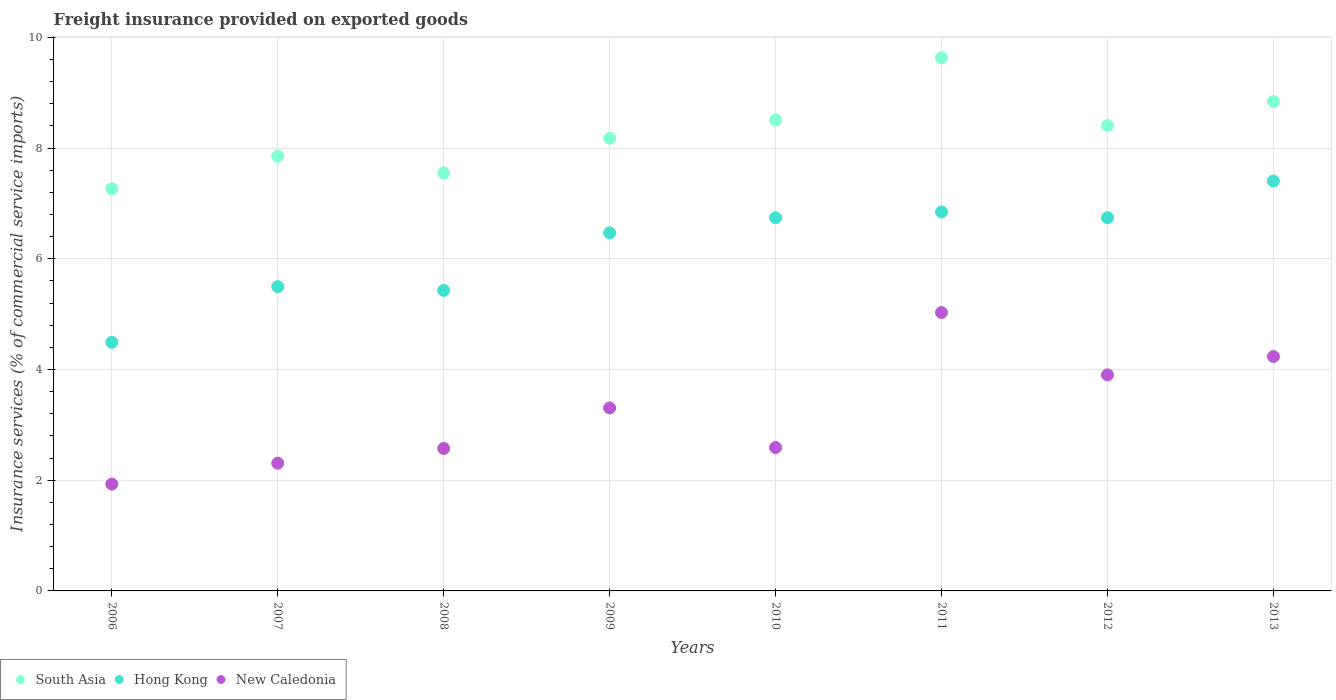What is the freight insurance provided on exported goods in South Asia in 2006?
Your answer should be very brief. 7.27. Across all years, what is the maximum freight insurance provided on exported goods in New Caledonia?
Make the answer very short. 5.03. Across all years, what is the minimum freight insurance provided on exported goods in New Caledonia?
Provide a succinct answer. 1.93. In which year was the freight insurance provided on exported goods in South Asia maximum?
Your response must be concise. 2011. In which year was the freight insurance provided on exported goods in New Caledonia minimum?
Give a very brief answer. 2006. What is the total freight insurance provided on exported goods in South Asia in the graph?
Your answer should be compact. 66.23. What is the difference between the freight insurance provided on exported goods in South Asia in 2006 and that in 2013?
Make the answer very short. -1.57. What is the difference between the freight insurance provided on exported goods in South Asia in 2011 and the freight insurance provided on exported goods in New Caledonia in 2012?
Ensure brevity in your answer.  5.73. What is the average freight insurance provided on exported goods in South Asia per year?
Your response must be concise. 8.28. In the year 2006, what is the difference between the freight insurance provided on exported goods in New Caledonia and freight insurance provided on exported goods in South Asia?
Your answer should be compact. -5.34. In how many years, is the freight insurance provided on exported goods in Hong Kong greater than 9.6 %?
Provide a short and direct response. 0. What is the ratio of the freight insurance provided on exported goods in Hong Kong in 2006 to that in 2013?
Offer a terse response. 0.61. Is the difference between the freight insurance provided on exported goods in New Caledonia in 2008 and 2010 greater than the difference between the freight insurance provided on exported goods in South Asia in 2008 and 2010?
Provide a short and direct response. Yes. What is the difference between the highest and the second highest freight insurance provided on exported goods in Hong Kong?
Make the answer very short. 0.56. What is the difference between the highest and the lowest freight insurance provided on exported goods in Hong Kong?
Your answer should be compact. 2.91. In how many years, is the freight insurance provided on exported goods in New Caledonia greater than the average freight insurance provided on exported goods in New Caledonia taken over all years?
Your answer should be compact. 4. Is the sum of the freight insurance provided on exported goods in New Caledonia in 2010 and 2012 greater than the maximum freight insurance provided on exported goods in Hong Kong across all years?
Offer a very short reply. No. Is it the case that in every year, the sum of the freight insurance provided on exported goods in South Asia and freight insurance provided on exported goods in New Caledonia  is greater than the freight insurance provided on exported goods in Hong Kong?
Make the answer very short. Yes. Is the freight insurance provided on exported goods in Hong Kong strictly greater than the freight insurance provided on exported goods in New Caledonia over the years?
Provide a short and direct response. Yes. How many dotlines are there?
Offer a terse response. 3. How many years are there in the graph?
Provide a succinct answer. 8. What is the difference between two consecutive major ticks on the Y-axis?
Offer a terse response. 2. Does the graph contain grids?
Offer a very short reply. Yes. How are the legend labels stacked?
Provide a short and direct response. Horizontal. What is the title of the graph?
Your response must be concise. Freight insurance provided on exported goods. Does "Myanmar" appear as one of the legend labels in the graph?
Keep it short and to the point. No. What is the label or title of the Y-axis?
Your answer should be compact. Insurance services (% of commercial service imports). What is the Insurance services (% of commercial service imports) of South Asia in 2006?
Keep it short and to the point. 7.27. What is the Insurance services (% of commercial service imports) in Hong Kong in 2006?
Offer a terse response. 4.49. What is the Insurance services (% of commercial service imports) in New Caledonia in 2006?
Your response must be concise. 1.93. What is the Insurance services (% of commercial service imports) in South Asia in 2007?
Offer a terse response. 7.85. What is the Insurance services (% of commercial service imports) in Hong Kong in 2007?
Your answer should be compact. 5.5. What is the Insurance services (% of commercial service imports) of New Caledonia in 2007?
Your response must be concise. 2.31. What is the Insurance services (% of commercial service imports) of South Asia in 2008?
Provide a succinct answer. 7.55. What is the Insurance services (% of commercial service imports) of Hong Kong in 2008?
Your answer should be very brief. 5.43. What is the Insurance services (% of commercial service imports) in New Caledonia in 2008?
Your response must be concise. 2.57. What is the Insurance services (% of commercial service imports) in South Asia in 2009?
Your answer should be very brief. 8.18. What is the Insurance services (% of commercial service imports) in Hong Kong in 2009?
Provide a succinct answer. 6.47. What is the Insurance services (% of commercial service imports) in New Caledonia in 2009?
Your answer should be compact. 3.31. What is the Insurance services (% of commercial service imports) of South Asia in 2010?
Provide a short and direct response. 8.51. What is the Insurance services (% of commercial service imports) of Hong Kong in 2010?
Make the answer very short. 6.74. What is the Insurance services (% of commercial service imports) in New Caledonia in 2010?
Make the answer very short. 2.59. What is the Insurance services (% of commercial service imports) in South Asia in 2011?
Ensure brevity in your answer.  9.63. What is the Insurance services (% of commercial service imports) of Hong Kong in 2011?
Provide a succinct answer. 6.85. What is the Insurance services (% of commercial service imports) of New Caledonia in 2011?
Offer a very short reply. 5.03. What is the Insurance services (% of commercial service imports) in South Asia in 2012?
Offer a terse response. 8.41. What is the Insurance services (% of commercial service imports) of Hong Kong in 2012?
Your answer should be very brief. 6.74. What is the Insurance services (% of commercial service imports) of New Caledonia in 2012?
Ensure brevity in your answer.  3.9. What is the Insurance services (% of commercial service imports) of South Asia in 2013?
Ensure brevity in your answer.  8.84. What is the Insurance services (% of commercial service imports) in Hong Kong in 2013?
Give a very brief answer. 7.4. What is the Insurance services (% of commercial service imports) in New Caledonia in 2013?
Offer a very short reply. 4.23. Across all years, what is the maximum Insurance services (% of commercial service imports) in South Asia?
Ensure brevity in your answer.  9.63. Across all years, what is the maximum Insurance services (% of commercial service imports) of Hong Kong?
Offer a very short reply. 7.4. Across all years, what is the maximum Insurance services (% of commercial service imports) in New Caledonia?
Your answer should be compact. 5.03. Across all years, what is the minimum Insurance services (% of commercial service imports) of South Asia?
Your response must be concise. 7.27. Across all years, what is the minimum Insurance services (% of commercial service imports) of Hong Kong?
Offer a very short reply. 4.49. Across all years, what is the minimum Insurance services (% of commercial service imports) of New Caledonia?
Your answer should be very brief. 1.93. What is the total Insurance services (% of commercial service imports) in South Asia in the graph?
Your response must be concise. 66.23. What is the total Insurance services (% of commercial service imports) of Hong Kong in the graph?
Your response must be concise. 49.62. What is the total Insurance services (% of commercial service imports) in New Caledonia in the graph?
Your response must be concise. 25.87. What is the difference between the Insurance services (% of commercial service imports) in South Asia in 2006 and that in 2007?
Offer a terse response. -0.59. What is the difference between the Insurance services (% of commercial service imports) of Hong Kong in 2006 and that in 2007?
Your answer should be very brief. -1.01. What is the difference between the Insurance services (% of commercial service imports) in New Caledonia in 2006 and that in 2007?
Ensure brevity in your answer.  -0.38. What is the difference between the Insurance services (% of commercial service imports) in South Asia in 2006 and that in 2008?
Ensure brevity in your answer.  -0.29. What is the difference between the Insurance services (% of commercial service imports) of Hong Kong in 2006 and that in 2008?
Offer a very short reply. -0.94. What is the difference between the Insurance services (% of commercial service imports) in New Caledonia in 2006 and that in 2008?
Provide a succinct answer. -0.64. What is the difference between the Insurance services (% of commercial service imports) in South Asia in 2006 and that in 2009?
Make the answer very short. -0.91. What is the difference between the Insurance services (% of commercial service imports) of Hong Kong in 2006 and that in 2009?
Keep it short and to the point. -1.98. What is the difference between the Insurance services (% of commercial service imports) in New Caledonia in 2006 and that in 2009?
Make the answer very short. -1.38. What is the difference between the Insurance services (% of commercial service imports) of South Asia in 2006 and that in 2010?
Make the answer very short. -1.24. What is the difference between the Insurance services (% of commercial service imports) of Hong Kong in 2006 and that in 2010?
Make the answer very short. -2.25. What is the difference between the Insurance services (% of commercial service imports) of New Caledonia in 2006 and that in 2010?
Give a very brief answer. -0.66. What is the difference between the Insurance services (% of commercial service imports) of South Asia in 2006 and that in 2011?
Provide a short and direct response. -2.36. What is the difference between the Insurance services (% of commercial service imports) in Hong Kong in 2006 and that in 2011?
Give a very brief answer. -2.35. What is the difference between the Insurance services (% of commercial service imports) of New Caledonia in 2006 and that in 2011?
Your answer should be very brief. -3.1. What is the difference between the Insurance services (% of commercial service imports) in South Asia in 2006 and that in 2012?
Ensure brevity in your answer.  -1.14. What is the difference between the Insurance services (% of commercial service imports) in Hong Kong in 2006 and that in 2012?
Your answer should be very brief. -2.25. What is the difference between the Insurance services (% of commercial service imports) of New Caledonia in 2006 and that in 2012?
Provide a succinct answer. -1.97. What is the difference between the Insurance services (% of commercial service imports) in South Asia in 2006 and that in 2013?
Offer a very short reply. -1.57. What is the difference between the Insurance services (% of commercial service imports) in Hong Kong in 2006 and that in 2013?
Make the answer very short. -2.91. What is the difference between the Insurance services (% of commercial service imports) of New Caledonia in 2006 and that in 2013?
Keep it short and to the point. -2.31. What is the difference between the Insurance services (% of commercial service imports) in South Asia in 2007 and that in 2008?
Offer a very short reply. 0.3. What is the difference between the Insurance services (% of commercial service imports) of Hong Kong in 2007 and that in 2008?
Ensure brevity in your answer.  0.07. What is the difference between the Insurance services (% of commercial service imports) of New Caledonia in 2007 and that in 2008?
Provide a short and direct response. -0.27. What is the difference between the Insurance services (% of commercial service imports) in South Asia in 2007 and that in 2009?
Your response must be concise. -0.32. What is the difference between the Insurance services (% of commercial service imports) of Hong Kong in 2007 and that in 2009?
Ensure brevity in your answer.  -0.97. What is the difference between the Insurance services (% of commercial service imports) of New Caledonia in 2007 and that in 2009?
Provide a short and direct response. -1. What is the difference between the Insurance services (% of commercial service imports) in South Asia in 2007 and that in 2010?
Keep it short and to the point. -0.66. What is the difference between the Insurance services (% of commercial service imports) in Hong Kong in 2007 and that in 2010?
Your answer should be very brief. -1.24. What is the difference between the Insurance services (% of commercial service imports) of New Caledonia in 2007 and that in 2010?
Give a very brief answer. -0.28. What is the difference between the Insurance services (% of commercial service imports) in South Asia in 2007 and that in 2011?
Give a very brief answer. -1.78. What is the difference between the Insurance services (% of commercial service imports) of Hong Kong in 2007 and that in 2011?
Your response must be concise. -1.35. What is the difference between the Insurance services (% of commercial service imports) of New Caledonia in 2007 and that in 2011?
Make the answer very short. -2.72. What is the difference between the Insurance services (% of commercial service imports) in South Asia in 2007 and that in 2012?
Provide a succinct answer. -0.56. What is the difference between the Insurance services (% of commercial service imports) of Hong Kong in 2007 and that in 2012?
Give a very brief answer. -1.25. What is the difference between the Insurance services (% of commercial service imports) of New Caledonia in 2007 and that in 2012?
Keep it short and to the point. -1.6. What is the difference between the Insurance services (% of commercial service imports) of South Asia in 2007 and that in 2013?
Ensure brevity in your answer.  -0.99. What is the difference between the Insurance services (% of commercial service imports) of Hong Kong in 2007 and that in 2013?
Provide a succinct answer. -1.91. What is the difference between the Insurance services (% of commercial service imports) in New Caledonia in 2007 and that in 2013?
Offer a terse response. -1.93. What is the difference between the Insurance services (% of commercial service imports) of South Asia in 2008 and that in 2009?
Provide a succinct answer. -0.63. What is the difference between the Insurance services (% of commercial service imports) in Hong Kong in 2008 and that in 2009?
Keep it short and to the point. -1.04. What is the difference between the Insurance services (% of commercial service imports) of New Caledonia in 2008 and that in 2009?
Your answer should be compact. -0.73. What is the difference between the Insurance services (% of commercial service imports) in South Asia in 2008 and that in 2010?
Keep it short and to the point. -0.96. What is the difference between the Insurance services (% of commercial service imports) of Hong Kong in 2008 and that in 2010?
Provide a short and direct response. -1.31. What is the difference between the Insurance services (% of commercial service imports) in New Caledonia in 2008 and that in 2010?
Provide a succinct answer. -0.02. What is the difference between the Insurance services (% of commercial service imports) in South Asia in 2008 and that in 2011?
Offer a terse response. -2.08. What is the difference between the Insurance services (% of commercial service imports) in Hong Kong in 2008 and that in 2011?
Your answer should be compact. -1.42. What is the difference between the Insurance services (% of commercial service imports) of New Caledonia in 2008 and that in 2011?
Offer a terse response. -2.46. What is the difference between the Insurance services (% of commercial service imports) of South Asia in 2008 and that in 2012?
Offer a very short reply. -0.86. What is the difference between the Insurance services (% of commercial service imports) of Hong Kong in 2008 and that in 2012?
Your answer should be compact. -1.31. What is the difference between the Insurance services (% of commercial service imports) in New Caledonia in 2008 and that in 2012?
Your answer should be very brief. -1.33. What is the difference between the Insurance services (% of commercial service imports) in South Asia in 2008 and that in 2013?
Give a very brief answer. -1.29. What is the difference between the Insurance services (% of commercial service imports) in Hong Kong in 2008 and that in 2013?
Make the answer very short. -1.98. What is the difference between the Insurance services (% of commercial service imports) of New Caledonia in 2008 and that in 2013?
Offer a very short reply. -1.66. What is the difference between the Insurance services (% of commercial service imports) in South Asia in 2009 and that in 2010?
Offer a very short reply. -0.33. What is the difference between the Insurance services (% of commercial service imports) in Hong Kong in 2009 and that in 2010?
Provide a succinct answer. -0.27. What is the difference between the Insurance services (% of commercial service imports) in New Caledonia in 2009 and that in 2010?
Provide a short and direct response. 0.71. What is the difference between the Insurance services (% of commercial service imports) of South Asia in 2009 and that in 2011?
Keep it short and to the point. -1.45. What is the difference between the Insurance services (% of commercial service imports) of Hong Kong in 2009 and that in 2011?
Give a very brief answer. -0.38. What is the difference between the Insurance services (% of commercial service imports) of New Caledonia in 2009 and that in 2011?
Offer a terse response. -1.72. What is the difference between the Insurance services (% of commercial service imports) in South Asia in 2009 and that in 2012?
Offer a very short reply. -0.23. What is the difference between the Insurance services (% of commercial service imports) of Hong Kong in 2009 and that in 2012?
Provide a short and direct response. -0.27. What is the difference between the Insurance services (% of commercial service imports) of New Caledonia in 2009 and that in 2012?
Offer a very short reply. -0.6. What is the difference between the Insurance services (% of commercial service imports) of South Asia in 2009 and that in 2013?
Offer a very short reply. -0.66. What is the difference between the Insurance services (% of commercial service imports) of Hong Kong in 2009 and that in 2013?
Your answer should be very brief. -0.94. What is the difference between the Insurance services (% of commercial service imports) in New Caledonia in 2009 and that in 2013?
Offer a very short reply. -0.93. What is the difference between the Insurance services (% of commercial service imports) in South Asia in 2010 and that in 2011?
Ensure brevity in your answer.  -1.12. What is the difference between the Insurance services (% of commercial service imports) in Hong Kong in 2010 and that in 2011?
Keep it short and to the point. -0.1. What is the difference between the Insurance services (% of commercial service imports) in New Caledonia in 2010 and that in 2011?
Provide a succinct answer. -2.44. What is the difference between the Insurance services (% of commercial service imports) of South Asia in 2010 and that in 2012?
Make the answer very short. 0.1. What is the difference between the Insurance services (% of commercial service imports) of Hong Kong in 2010 and that in 2012?
Provide a short and direct response. -0. What is the difference between the Insurance services (% of commercial service imports) of New Caledonia in 2010 and that in 2012?
Make the answer very short. -1.31. What is the difference between the Insurance services (% of commercial service imports) of South Asia in 2010 and that in 2013?
Provide a succinct answer. -0.33. What is the difference between the Insurance services (% of commercial service imports) in Hong Kong in 2010 and that in 2013?
Make the answer very short. -0.66. What is the difference between the Insurance services (% of commercial service imports) in New Caledonia in 2010 and that in 2013?
Provide a succinct answer. -1.64. What is the difference between the Insurance services (% of commercial service imports) of South Asia in 2011 and that in 2012?
Your answer should be compact. 1.22. What is the difference between the Insurance services (% of commercial service imports) of Hong Kong in 2011 and that in 2012?
Offer a very short reply. 0.1. What is the difference between the Insurance services (% of commercial service imports) of New Caledonia in 2011 and that in 2012?
Your response must be concise. 1.13. What is the difference between the Insurance services (% of commercial service imports) in South Asia in 2011 and that in 2013?
Your answer should be very brief. 0.79. What is the difference between the Insurance services (% of commercial service imports) in Hong Kong in 2011 and that in 2013?
Keep it short and to the point. -0.56. What is the difference between the Insurance services (% of commercial service imports) in New Caledonia in 2011 and that in 2013?
Your answer should be compact. 0.79. What is the difference between the Insurance services (% of commercial service imports) of South Asia in 2012 and that in 2013?
Your response must be concise. -0.43. What is the difference between the Insurance services (% of commercial service imports) of Hong Kong in 2012 and that in 2013?
Offer a terse response. -0.66. What is the difference between the Insurance services (% of commercial service imports) in New Caledonia in 2012 and that in 2013?
Provide a succinct answer. -0.33. What is the difference between the Insurance services (% of commercial service imports) in South Asia in 2006 and the Insurance services (% of commercial service imports) in Hong Kong in 2007?
Provide a succinct answer. 1.77. What is the difference between the Insurance services (% of commercial service imports) in South Asia in 2006 and the Insurance services (% of commercial service imports) in New Caledonia in 2007?
Your response must be concise. 4.96. What is the difference between the Insurance services (% of commercial service imports) of Hong Kong in 2006 and the Insurance services (% of commercial service imports) of New Caledonia in 2007?
Provide a succinct answer. 2.18. What is the difference between the Insurance services (% of commercial service imports) in South Asia in 2006 and the Insurance services (% of commercial service imports) in Hong Kong in 2008?
Your response must be concise. 1.84. What is the difference between the Insurance services (% of commercial service imports) of South Asia in 2006 and the Insurance services (% of commercial service imports) of New Caledonia in 2008?
Make the answer very short. 4.69. What is the difference between the Insurance services (% of commercial service imports) of Hong Kong in 2006 and the Insurance services (% of commercial service imports) of New Caledonia in 2008?
Make the answer very short. 1.92. What is the difference between the Insurance services (% of commercial service imports) of South Asia in 2006 and the Insurance services (% of commercial service imports) of Hong Kong in 2009?
Give a very brief answer. 0.8. What is the difference between the Insurance services (% of commercial service imports) in South Asia in 2006 and the Insurance services (% of commercial service imports) in New Caledonia in 2009?
Make the answer very short. 3.96. What is the difference between the Insurance services (% of commercial service imports) in Hong Kong in 2006 and the Insurance services (% of commercial service imports) in New Caledonia in 2009?
Your answer should be very brief. 1.19. What is the difference between the Insurance services (% of commercial service imports) of South Asia in 2006 and the Insurance services (% of commercial service imports) of Hong Kong in 2010?
Your response must be concise. 0.52. What is the difference between the Insurance services (% of commercial service imports) of South Asia in 2006 and the Insurance services (% of commercial service imports) of New Caledonia in 2010?
Ensure brevity in your answer.  4.68. What is the difference between the Insurance services (% of commercial service imports) of Hong Kong in 2006 and the Insurance services (% of commercial service imports) of New Caledonia in 2010?
Your answer should be very brief. 1.9. What is the difference between the Insurance services (% of commercial service imports) of South Asia in 2006 and the Insurance services (% of commercial service imports) of Hong Kong in 2011?
Provide a succinct answer. 0.42. What is the difference between the Insurance services (% of commercial service imports) of South Asia in 2006 and the Insurance services (% of commercial service imports) of New Caledonia in 2011?
Provide a succinct answer. 2.24. What is the difference between the Insurance services (% of commercial service imports) of Hong Kong in 2006 and the Insurance services (% of commercial service imports) of New Caledonia in 2011?
Provide a short and direct response. -0.54. What is the difference between the Insurance services (% of commercial service imports) of South Asia in 2006 and the Insurance services (% of commercial service imports) of Hong Kong in 2012?
Offer a very short reply. 0.52. What is the difference between the Insurance services (% of commercial service imports) in South Asia in 2006 and the Insurance services (% of commercial service imports) in New Caledonia in 2012?
Keep it short and to the point. 3.36. What is the difference between the Insurance services (% of commercial service imports) in Hong Kong in 2006 and the Insurance services (% of commercial service imports) in New Caledonia in 2012?
Give a very brief answer. 0.59. What is the difference between the Insurance services (% of commercial service imports) in South Asia in 2006 and the Insurance services (% of commercial service imports) in Hong Kong in 2013?
Provide a short and direct response. -0.14. What is the difference between the Insurance services (% of commercial service imports) in South Asia in 2006 and the Insurance services (% of commercial service imports) in New Caledonia in 2013?
Offer a very short reply. 3.03. What is the difference between the Insurance services (% of commercial service imports) in Hong Kong in 2006 and the Insurance services (% of commercial service imports) in New Caledonia in 2013?
Give a very brief answer. 0.26. What is the difference between the Insurance services (% of commercial service imports) in South Asia in 2007 and the Insurance services (% of commercial service imports) in Hong Kong in 2008?
Provide a succinct answer. 2.42. What is the difference between the Insurance services (% of commercial service imports) of South Asia in 2007 and the Insurance services (% of commercial service imports) of New Caledonia in 2008?
Provide a short and direct response. 5.28. What is the difference between the Insurance services (% of commercial service imports) of Hong Kong in 2007 and the Insurance services (% of commercial service imports) of New Caledonia in 2008?
Ensure brevity in your answer.  2.92. What is the difference between the Insurance services (% of commercial service imports) in South Asia in 2007 and the Insurance services (% of commercial service imports) in Hong Kong in 2009?
Offer a terse response. 1.38. What is the difference between the Insurance services (% of commercial service imports) of South Asia in 2007 and the Insurance services (% of commercial service imports) of New Caledonia in 2009?
Provide a succinct answer. 4.55. What is the difference between the Insurance services (% of commercial service imports) in Hong Kong in 2007 and the Insurance services (% of commercial service imports) in New Caledonia in 2009?
Provide a short and direct response. 2.19. What is the difference between the Insurance services (% of commercial service imports) in South Asia in 2007 and the Insurance services (% of commercial service imports) in Hong Kong in 2010?
Give a very brief answer. 1.11. What is the difference between the Insurance services (% of commercial service imports) in South Asia in 2007 and the Insurance services (% of commercial service imports) in New Caledonia in 2010?
Ensure brevity in your answer.  5.26. What is the difference between the Insurance services (% of commercial service imports) in Hong Kong in 2007 and the Insurance services (% of commercial service imports) in New Caledonia in 2010?
Give a very brief answer. 2.91. What is the difference between the Insurance services (% of commercial service imports) of South Asia in 2007 and the Insurance services (% of commercial service imports) of New Caledonia in 2011?
Give a very brief answer. 2.82. What is the difference between the Insurance services (% of commercial service imports) in Hong Kong in 2007 and the Insurance services (% of commercial service imports) in New Caledonia in 2011?
Keep it short and to the point. 0.47. What is the difference between the Insurance services (% of commercial service imports) in South Asia in 2007 and the Insurance services (% of commercial service imports) in Hong Kong in 2012?
Give a very brief answer. 1.11. What is the difference between the Insurance services (% of commercial service imports) in South Asia in 2007 and the Insurance services (% of commercial service imports) in New Caledonia in 2012?
Provide a succinct answer. 3.95. What is the difference between the Insurance services (% of commercial service imports) of Hong Kong in 2007 and the Insurance services (% of commercial service imports) of New Caledonia in 2012?
Your answer should be compact. 1.59. What is the difference between the Insurance services (% of commercial service imports) in South Asia in 2007 and the Insurance services (% of commercial service imports) in Hong Kong in 2013?
Give a very brief answer. 0.45. What is the difference between the Insurance services (% of commercial service imports) in South Asia in 2007 and the Insurance services (% of commercial service imports) in New Caledonia in 2013?
Your answer should be compact. 3.62. What is the difference between the Insurance services (% of commercial service imports) of Hong Kong in 2007 and the Insurance services (% of commercial service imports) of New Caledonia in 2013?
Provide a short and direct response. 1.26. What is the difference between the Insurance services (% of commercial service imports) in South Asia in 2008 and the Insurance services (% of commercial service imports) in Hong Kong in 2009?
Ensure brevity in your answer.  1.08. What is the difference between the Insurance services (% of commercial service imports) of South Asia in 2008 and the Insurance services (% of commercial service imports) of New Caledonia in 2009?
Your response must be concise. 4.25. What is the difference between the Insurance services (% of commercial service imports) in Hong Kong in 2008 and the Insurance services (% of commercial service imports) in New Caledonia in 2009?
Provide a short and direct response. 2.12. What is the difference between the Insurance services (% of commercial service imports) in South Asia in 2008 and the Insurance services (% of commercial service imports) in Hong Kong in 2010?
Offer a terse response. 0.81. What is the difference between the Insurance services (% of commercial service imports) in South Asia in 2008 and the Insurance services (% of commercial service imports) in New Caledonia in 2010?
Keep it short and to the point. 4.96. What is the difference between the Insurance services (% of commercial service imports) of Hong Kong in 2008 and the Insurance services (% of commercial service imports) of New Caledonia in 2010?
Ensure brevity in your answer.  2.84. What is the difference between the Insurance services (% of commercial service imports) of South Asia in 2008 and the Insurance services (% of commercial service imports) of Hong Kong in 2011?
Provide a short and direct response. 0.71. What is the difference between the Insurance services (% of commercial service imports) of South Asia in 2008 and the Insurance services (% of commercial service imports) of New Caledonia in 2011?
Offer a terse response. 2.52. What is the difference between the Insurance services (% of commercial service imports) of Hong Kong in 2008 and the Insurance services (% of commercial service imports) of New Caledonia in 2011?
Ensure brevity in your answer.  0.4. What is the difference between the Insurance services (% of commercial service imports) of South Asia in 2008 and the Insurance services (% of commercial service imports) of Hong Kong in 2012?
Give a very brief answer. 0.81. What is the difference between the Insurance services (% of commercial service imports) of South Asia in 2008 and the Insurance services (% of commercial service imports) of New Caledonia in 2012?
Keep it short and to the point. 3.65. What is the difference between the Insurance services (% of commercial service imports) of Hong Kong in 2008 and the Insurance services (% of commercial service imports) of New Caledonia in 2012?
Provide a short and direct response. 1.53. What is the difference between the Insurance services (% of commercial service imports) in South Asia in 2008 and the Insurance services (% of commercial service imports) in Hong Kong in 2013?
Keep it short and to the point. 0.15. What is the difference between the Insurance services (% of commercial service imports) in South Asia in 2008 and the Insurance services (% of commercial service imports) in New Caledonia in 2013?
Give a very brief answer. 3.32. What is the difference between the Insurance services (% of commercial service imports) of Hong Kong in 2008 and the Insurance services (% of commercial service imports) of New Caledonia in 2013?
Keep it short and to the point. 1.19. What is the difference between the Insurance services (% of commercial service imports) of South Asia in 2009 and the Insurance services (% of commercial service imports) of Hong Kong in 2010?
Provide a short and direct response. 1.44. What is the difference between the Insurance services (% of commercial service imports) in South Asia in 2009 and the Insurance services (% of commercial service imports) in New Caledonia in 2010?
Give a very brief answer. 5.59. What is the difference between the Insurance services (% of commercial service imports) of Hong Kong in 2009 and the Insurance services (% of commercial service imports) of New Caledonia in 2010?
Ensure brevity in your answer.  3.88. What is the difference between the Insurance services (% of commercial service imports) in South Asia in 2009 and the Insurance services (% of commercial service imports) in Hong Kong in 2011?
Offer a terse response. 1.33. What is the difference between the Insurance services (% of commercial service imports) in South Asia in 2009 and the Insurance services (% of commercial service imports) in New Caledonia in 2011?
Provide a short and direct response. 3.15. What is the difference between the Insurance services (% of commercial service imports) of Hong Kong in 2009 and the Insurance services (% of commercial service imports) of New Caledonia in 2011?
Offer a very short reply. 1.44. What is the difference between the Insurance services (% of commercial service imports) in South Asia in 2009 and the Insurance services (% of commercial service imports) in Hong Kong in 2012?
Offer a very short reply. 1.43. What is the difference between the Insurance services (% of commercial service imports) in South Asia in 2009 and the Insurance services (% of commercial service imports) in New Caledonia in 2012?
Ensure brevity in your answer.  4.27. What is the difference between the Insurance services (% of commercial service imports) of Hong Kong in 2009 and the Insurance services (% of commercial service imports) of New Caledonia in 2012?
Your answer should be very brief. 2.57. What is the difference between the Insurance services (% of commercial service imports) of South Asia in 2009 and the Insurance services (% of commercial service imports) of Hong Kong in 2013?
Provide a succinct answer. 0.77. What is the difference between the Insurance services (% of commercial service imports) of South Asia in 2009 and the Insurance services (% of commercial service imports) of New Caledonia in 2013?
Offer a very short reply. 3.94. What is the difference between the Insurance services (% of commercial service imports) of Hong Kong in 2009 and the Insurance services (% of commercial service imports) of New Caledonia in 2013?
Ensure brevity in your answer.  2.23. What is the difference between the Insurance services (% of commercial service imports) in South Asia in 2010 and the Insurance services (% of commercial service imports) in Hong Kong in 2011?
Provide a succinct answer. 1.66. What is the difference between the Insurance services (% of commercial service imports) of South Asia in 2010 and the Insurance services (% of commercial service imports) of New Caledonia in 2011?
Your response must be concise. 3.48. What is the difference between the Insurance services (% of commercial service imports) of Hong Kong in 2010 and the Insurance services (% of commercial service imports) of New Caledonia in 2011?
Provide a succinct answer. 1.71. What is the difference between the Insurance services (% of commercial service imports) in South Asia in 2010 and the Insurance services (% of commercial service imports) in Hong Kong in 2012?
Your response must be concise. 1.77. What is the difference between the Insurance services (% of commercial service imports) of South Asia in 2010 and the Insurance services (% of commercial service imports) of New Caledonia in 2012?
Your response must be concise. 4.6. What is the difference between the Insurance services (% of commercial service imports) in Hong Kong in 2010 and the Insurance services (% of commercial service imports) in New Caledonia in 2012?
Your answer should be compact. 2.84. What is the difference between the Insurance services (% of commercial service imports) in South Asia in 2010 and the Insurance services (% of commercial service imports) in Hong Kong in 2013?
Keep it short and to the point. 1.1. What is the difference between the Insurance services (% of commercial service imports) in South Asia in 2010 and the Insurance services (% of commercial service imports) in New Caledonia in 2013?
Your answer should be very brief. 4.27. What is the difference between the Insurance services (% of commercial service imports) in Hong Kong in 2010 and the Insurance services (% of commercial service imports) in New Caledonia in 2013?
Your answer should be very brief. 2.51. What is the difference between the Insurance services (% of commercial service imports) of South Asia in 2011 and the Insurance services (% of commercial service imports) of Hong Kong in 2012?
Offer a very short reply. 2.89. What is the difference between the Insurance services (% of commercial service imports) in South Asia in 2011 and the Insurance services (% of commercial service imports) in New Caledonia in 2012?
Keep it short and to the point. 5.73. What is the difference between the Insurance services (% of commercial service imports) of Hong Kong in 2011 and the Insurance services (% of commercial service imports) of New Caledonia in 2012?
Make the answer very short. 2.94. What is the difference between the Insurance services (% of commercial service imports) of South Asia in 2011 and the Insurance services (% of commercial service imports) of Hong Kong in 2013?
Provide a short and direct response. 2.22. What is the difference between the Insurance services (% of commercial service imports) of South Asia in 2011 and the Insurance services (% of commercial service imports) of New Caledonia in 2013?
Ensure brevity in your answer.  5.39. What is the difference between the Insurance services (% of commercial service imports) of Hong Kong in 2011 and the Insurance services (% of commercial service imports) of New Caledonia in 2013?
Your answer should be compact. 2.61. What is the difference between the Insurance services (% of commercial service imports) of South Asia in 2012 and the Insurance services (% of commercial service imports) of Hong Kong in 2013?
Keep it short and to the point. 1. What is the difference between the Insurance services (% of commercial service imports) in South Asia in 2012 and the Insurance services (% of commercial service imports) in New Caledonia in 2013?
Offer a very short reply. 4.17. What is the difference between the Insurance services (% of commercial service imports) of Hong Kong in 2012 and the Insurance services (% of commercial service imports) of New Caledonia in 2013?
Ensure brevity in your answer.  2.51. What is the average Insurance services (% of commercial service imports) of South Asia per year?
Make the answer very short. 8.28. What is the average Insurance services (% of commercial service imports) of Hong Kong per year?
Give a very brief answer. 6.2. What is the average Insurance services (% of commercial service imports) in New Caledonia per year?
Make the answer very short. 3.23. In the year 2006, what is the difference between the Insurance services (% of commercial service imports) of South Asia and Insurance services (% of commercial service imports) of Hong Kong?
Your answer should be very brief. 2.77. In the year 2006, what is the difference between the Insurance services (% of commercial service imports) of South Asia and Insurance services (% of commercial service imports) of New Caledonia?
Your response must be concise. 5.34. In the year 2006, what is the difference between the Insurance services (% of commercial service imports) in Hong Kong and Insurance services (% of commercial service imports) in New Caledonia?
Ensure brevity in your answer.  2.56. In the year 2007, what is the difference between the Insurance services (% of commercial service imports) of South Asia and Insurance services (% of commercial service imports) of Hong Kong?
Give a very brief answer. 2.36. In the year 2007, what is the difference between the Insurance services (% of commercial service imports) in South Asia and Insurance services (% of commercial service imports) in New Caledonia?
Give a very brief answer. 5.55. In the year 2007, what is the difference between the Insurance services (% of commercial service imports) in Hong Kong and Insurance services (% of commercial service imports) in New Caledonia?
Offer a very short reply. 3.19. In the year 2008, what is the difference between the Insurance services (% of commercial service imports) in South Asia and Insurance services (% of commercial service imports) in Hong Kong?
Make the answer very short. 2.12. In the year 2008, what is the difference between the Insurance services (% of commercial service imports) of South Asia and Insurance services (% of commercial service imports) of New Caledonia?
Make the answer very short. 4.98. In the year 2008, what is the difference between the Insurance services (% of commercial service imports) of Hong Kong and Insurance services (% of commercial service imports) of New Caledonia?
Offer a terse response. 2.85. In the year 2009, what is the difference between the Insurance services (% of commercial service imports) in South Asia and Insurance services (% of commercial service imports) in Hong Kong?
Give a very brief answer. 1.71. In the year 2009, what is the difference between the Insurance services (% of commercial service imports) of South Asia and Insurance services (% of commercial service imports) of New Caledonia?
Provide a succinct answer. 4.87. In the year 2009, what is the difference between the Insurance services (% of commercial service imports) of Hong Kong and Insurance services (% of commercial service imports) of New Caledonia?
Your answer should be very brief. 3.16. In the year 2010, what is the difference between the Insurance services (% of commercial service imports) in South Asia and Insurance services (% of commercial service imports) in Hong Kong?
Make the answer very short. 1.77. In the year 2010, what is the difference between the Insurance services (% of commercial service imports) of South Asia and Insurance services (% of commercial service imports) of New Caledonia?
Keep it short and to the point. 5.92. In the year 2010, what is the difference between the Insurance services (% of commercial service imports) of Hong Kong and Insurance services (% of commercial service imports) of New Caledonia?
Provide a succinct answer. 4.15. In the year 2011, what is the difference between the Insurance services (% of commercial service imports) in South Asia and Insurance services (% of commercial service imports) in Hong Kong?
Provide a short and direct response. 2.78. In the year 2011, what is the difference between the Insurance services (% of commercial service imports) of South Asia and Insurance services (% of commercial service imports) of New Caledonia?
Keep it short and to the point. 4.6. In the year 2011, what is the difference between the Insurance services (% of commercial service imports) of Hong Kong and Insurance services (% of commercial service imports) of New Caledonia?
Your answer should be very brief. 1.82. In the year 2012, what is the difference between the Insurance services (% of commercial service imports) in South Asia and Insurance services (% of commercial service imports) in Hong Kong?
Give a very brief answer. 1.67. In the year 2012, what is the difference between the Insurance services (% of commercial service imports) of South Asia and Insurance services (% of commercial service imports) of New Caledonia?
Your answer should be compact. 4.51. In the year 2012, what is the difference between the Insurance services (% of commercial service imports) of Hong Kong and Insurance services (% of commercial service imports) of New Caledonia?
Offer a very short reply. 2.84. In the year 2013, what is the difference between the Insurance services (% of commercial service imports) in South Asia and Insurance services (% of commercial service imports) in Hong Kong?
Offer a terse response. 1.43. In the year 2013, what is the difference between the Insurance services (% of commercial service imports) of South Asia and Insurance services (% of commercial service imports) of New Caledonia?
Your answer should be compact. 4.6. In the year 2013, what is the difference between the Insurance services (% of commercial service imports) in Hong Kong and Insurance services (% of commercial service imports) in New Caledonia?
Give a very brief answer. 3.17. What is the ratio of the Insurance services (% of commercial service imports) of South Asia in 2006 to that in 2007?
Your response must be concise. 0.93. What is the ratio of the Insurance services (% of commercial service imports) in Hong Kong in 2006 to that in 2007?
Provide a short and direct response. 0.82. What is the ratio of the Insurance services (% of commercial service imports) of New Caledonia in 2006 to that in 2007?
Provide a short and direct response. 0.84. What is the ratio of the Insurance services (% of commercial service imports) of South Asia in 2006 to that in 2008?
Give a very brief answer. 0.96. What is the ratio of the Insurance services (% of commercial service imports) of Hong Kong in 2006 to that in 2008?
Ensure brevity in your answer.  0.83. What is the ratio of the Insurance services (% of commercial service imports) of New Caledonia in 2006 to that in 2008?
Your response must be concise. 0.75. What is the ratio of the Insurance services (% of commercial service imports) in South Asia in 2006 to that in 2009?
Your response must be concise. 0.89. What is the ratio of the Insurance services (% of commercial service imports) of Hong Kong in 2006 to that in 2009?
Offer a very short reply. 0.69. What is the ratio of the Insurance services (% of commercial service imports) in New Caledonia in 2006 to that in 2009?
Your answer should be compact. 0.58. What is the ratio of the Insurance services (% of commercial service imports) in South Asia in 2006 to that in 2010?
Make the answer very short. 0.85. What is the ratio of the Insurance services (% of commercial service imports) of Hong Kong in 2006 to that in 2010?
Keep it short and to the point. 0.67. What is the ratio of the Insurance services (% of commercial service imports) in New Caledonia in 2006 to that in 2010?
Provide a succinct answer. 0.74. What is the ratio of the Insurance services (% of commercial service imports) of South Asia in 2006 to that in 2011?
Make the answer very short. 0.75. What is the ratio of the Insurance services (% of commercial service imports) of Hong Kong in 2006 to that in 2011?
Make the answer very short. 0.66. What is the ratio of the Insurance services (% of commercial service imports) in New Caledonia in 2006 to that in 2011?
Provide a short and direct response. 0.38. What is the ratio of the Insurance services (% of commercial service imports) in South Asia in 2006 to that in 2012?
Provide a succinct answer. 0.86. What is the ratio of the Insurance services (% of commercial service imports) of Hong Kong in 2006 to that in 2012?
Your answer should be very brief. 0.67. What is the ratio of the Insurance services (% of commercial service imports) in New Caledonia in 2006 to that in 2012?
Give a very brief answer. 0.49. What is the ratio of the Insurance services (% of commercial service imports) of South Asia in 2006 to that in 2013?
Offer a very short reply. 0.82. What is the ratio of the Insurance services (% of commercial service imports) of Hong Kong in 2006 to that in 2013?
Your response must be concise. 0.61. What is the ratio of the Insurance services (% of commercial service imports) in New Caledonia in 2006 to that in 2013?
Offer a terse response. 0.46. What is the ratio of the Insurance services (% of commercial service imports) in South Asia in 2007 to that in 2008?
Your answer should be very brief. 1.04. What is the ratio of the Insurance services (% of commercial service imports) of Hong Kong in 2007 to that in 2008?
Make the answer very short. 1.01. What is the ratio of the Insurance services (% of commercial service imports) of New Caledonia in 2007 to that in 2008?
Offer a terse response. 0.9. What is the ratio of the Insurance services (% of commercial service imports) of South Asia in 2007 to that in 2009?
Your response must be concise. 0.96. What is the ratio of the Insurance services (% of commercial service imports) in Hong Kong in 2007 to that in 2009?
Your answer should be compact. 0.85. What is the ratio of the Insurance services (% of commercial service imports) in New Caledonia in 2007 to that in 2009?
Your response must be concise. 0.7. What is the ratio of the Insurance services (% of commercial service imports) in South Asia in 2007 to that in 2010?
Your response must be concise. 0.92. What is the ratio of the Insurance services (% of commercial service imports) of Hong Kong in 2007 to that in 2010?
Your answer should be very brief. 0.82. What is the ratio of the Insurance services (% of commercial service imports) in New Caledonia in 2007 to that in 2010?
Make the answer very short. 0.89. What is the ratio of the Insurance services (% of commercial service imports) of South Asia in 2007 to that in 2011?
Your answer should be very brief. 0.82. What is the ratio of the Insurance services (% of commercial service imports) in Hong Kong in 2007 to that in 2011?
Provide a succinct answer. 0.8. What is the ratio of the Insurance services (% of commercial service imports) in New Caledonia in 2007 to that in 2011?
Provide a short and direct response. 0.46. What is the ratio of the Insurance services (% of commercial service imports) in South Asia in 2007 to that in 2012?
Offer a very short reply. 0.93. What is the ratio of the Insurance services (% of commercial service imports) of Hong Kong in 2007 to that in 2012?
Keep it short and to the point. 0.82. What is the ratio of the Insurance services (% of commercial service imports) in New Caledonia in 2007 to that in 2012?
Ensure brevity in your answer.  0.59. What is the ratio of the Insurance services (% of commercial service imports) of South Asia in 2007 to that in 2013?
Your response must be concise. 0.89. What is the ratio of the Insurance services (% of commercial service imports) of Hong Kong in 2007 to that in 2013?
Provide a succinct answer. 0.74. What is the ratio of the Insurance services (% of commercial service imports) of New Caledonia in 2007 to that in 2013?
Provide a succinct answer. 0.54. What is the ratio of the Insurance services (% of commercial service imports) of South Asia in 2008 to that in 2009?
Offer a very short reply. 0.92. What is the ratio of the Insurance services (% of commercial service imports) of Hong Kong in 2008 to that in 2009?
Offer a very short reply. 0.84. What is the ratio of the Insurance services (% of commercial service imports) of New Caledonia in 2008 to that in 2009?
Ensure brevity in your answer.  0.78. What is the ratio of the Insurance services (% of commercial service imports) in South Asia in 2008 to that in 2010?
Offer a very short reply. 0.89. What is the ratio of the Insurance services (% of commercial service imports) of Hong Kong in 2008 to that in 2010?
Ensure brevity in your answer.  0.81. What is the ratio of the Insurance services (% of commercial service imports) of New Caledonia in 2008 to that in 2010?
Make the answer very short. 0.99. What is the ratio of the Insurance services (% of commercial service imports) in South Asia in 2008 to that in 2011?
Offer a terse response. 0.78. What is the ratio of the Insurance services (% of commercial service imports) in Hong Kong in 2008 to that in 2011?
Your response must be concise. 0.79. What is the ratio of the Insurance services (% of commercial service imports) in New Caledonia in 2008 to that in 2011?
Keep it short and to the point. 0.51. What is the ratio of the Insurance services (% of commercial service imports) of South Asia in 2008 to that in 2012?
Make the answer very short. 0.9. What is the ratio of the Insurance services (% of commercial service imports) of Hong Kong in 2008 to that in 2012?
Provide a short and direct response. 0.81. What is the ratio of the Insurance services (% of commercial service imports) of New Caledonia in 2008 to that in 2012?
Your answer should be very brief. 0.66. What is the ratio of the Insurance services (% of commercial service imports) in South Asia in 2008 to that in 2013?
Offer a terse response. 0.85. What is the ratio of the Insurance services (% of commercial service imports) of Hong Kong in 2008 to that in 2013?
Provide a short and direct response. 0.73. What is the ratio of the Insurance services (% of commercial service imports) of New Caledonia in 2008 to that in 2013?
Provide a short and direct response. 0.61. What is the ratio of the Insurance services (% of commercial service imports) of South Asia in 2009 to that in 2010?
Ensure brevity in your answer.  0.96. What is the ratio of the Insurance services (% of commercial service imports) in Hong Kong in 2009 to that in 2010?
Provide a succinct answer. 0.96. What is the ratio of the Insurance services (% of commercial service imports) in New Caledonia in 2009 to that in 2010?
Give a very brief answer. 1.28. What is the ratio of the Insurance services (% of commercial service imports) in South Asia in 2009 to that in 2011?
Provide a succinct answer. 0.85. What is the ratio of the Insurance services (% of commercial service imports) of Hong Kong in 2009 to that in 2011?
Ensure brevity in your answer.  0.94. What is the ratio of the Insurance services (% of commercial service imports) of New Caledonia in 2009 to that in 2011?
Give a very brief answer. 0.66. What is the ratio of the Insurance services (% of commercial service imports) in South Asia in 2009 to that in 2012?
Your response must be concise. 0.97. What is the ratio of the Insurance services (% of commercial service imports) in Hong Kong in 2009 to that in 2012?
Give a very brief answer. 0.96. What is the ratio of the Insurance services (% of commercial service imports) in New Caledonia in 2009 to that in 2012?
Provide a succinct answer. 0.85. What is the ratio of the Insurance services (% of commercial service imports) in South Asia in 2009 to that in 2013?
Your answer should be very brief. 0.93. What is the ratio of the Insurance services (% of commercial service imports) of Hong Kong in 2009 to that in 2013?
Ensure brevity in your answer.  0.87. What is the ratio of the Insurance services (% of commercial service imports) in New Caledonia in 2009 to that in 2013?
Offer a terse response. 0.78. What is the ratio of the Insurance services (% of commercial service imports) of South Asia in 2010 to that in 2011?
Offer a very short reply. 0.88. What is the ratio of the Insurance services (% of commercial service imports) of New Caledonia in 2010 to that in 2011?
Make the answer very short. 0.52. What is the ratio of the Insurance services (% of commercial service imports) of South Asia in 2010 to that in 2012?
Offer a very short reply. 1.01. What is the ratio of the Insurance services (% of commercial service imports) of Hong Kong in 2010 to that in 2012?
Your response must be concise. 1. What is the ratio of the Insurance services (% of commercial service imports) in New Caledonia in 2010 to that in 2012?
Offer a terse response. 0.66. What is the ratio of the Insurance services (% of commercial service imports) in South Asia in 2010 to that in 2013?
Your response must be concise. 0.96. What is the ratio of the Insurance services (% of commercial service imports) in Hong Kong in 2010 to that in 2013?
Offer a terse response. 0.91. What is the ratio of the Insurance services (% of commercial service imports) of New Caledonia in 2010 to that in 2013?
Keep it short and to the point. 0.61. What is the ratio of the Insurance services (% of commercial service imports) in South Asia in 2011 to that in 2012?
Make the answer very short. 1.15. What is the ratio of the Insurance services (% of commercial service imports) of Hong Kong in 2011 to that in 2012?
Provide a short and direct response. 1.02. What is the ratio of the Insurance services (% of commercial service imports) in New Caledonia in 2011 to that in 2012?
Make the answer very short. 1.29. What is the ratio of the Insurance services (% of commercial service imports) in South Asia in 2011 to that in 2013?
Your response must be concise. 1.09. What is the ratio of the Insurance services (% of commercial service imports) of Hong Kong in 2011 to that in 2013?
Offer a very short reply. 0.92. What is the ratio of the Insurance services (% of commercial service imports) in New Caledonia in 2011 to that in 2013?
Ensure brevity in your answer.  1.19. What is the ratio of the Insurance services (% of commercial service imports) of South Asia in 2012 to that in 2013?
Ensure brevity in your answer.  0.95. What is the ratio of the Insurance services (% of commercial service imports) of Hong Kong in 2012 to that in 2013?
Your answer should be compact. 0.91. What is the ratio of the Insurance services (% of commercial service imports) of New Caledonia in 2012 to that in 2013?
Give a very brief answer. 0.92. What is the difference between the highest and the second highest Insurance services (% of commercial service imports) in South Asia?
Provide a succinct answer. 0.79. What is the difference between the highest and the second highest Insurance services (% of commercial service imports) of Hong Kong?
Your answer should be compact. 0.56. What is the difference between the highest and the second highest Insurance services (% of commercial service imports) in New Caledonia?
Keep it short and to the point. 0.79. What is the difference between the highest and the lowest Insurance services (% of commercial service imports) in South Asia?
Provide a succinct answer. 2.36. What is the difference between the highest and the lowest Insurance services (% of commercial service imports) of Hong Kong?
Ensure brevity in your answer.  2.91. What is the difference between the highest and the lowest Insurance services (% of commercial service imports) of New Caledonia?
Provide a short and direct response. 3.1. 